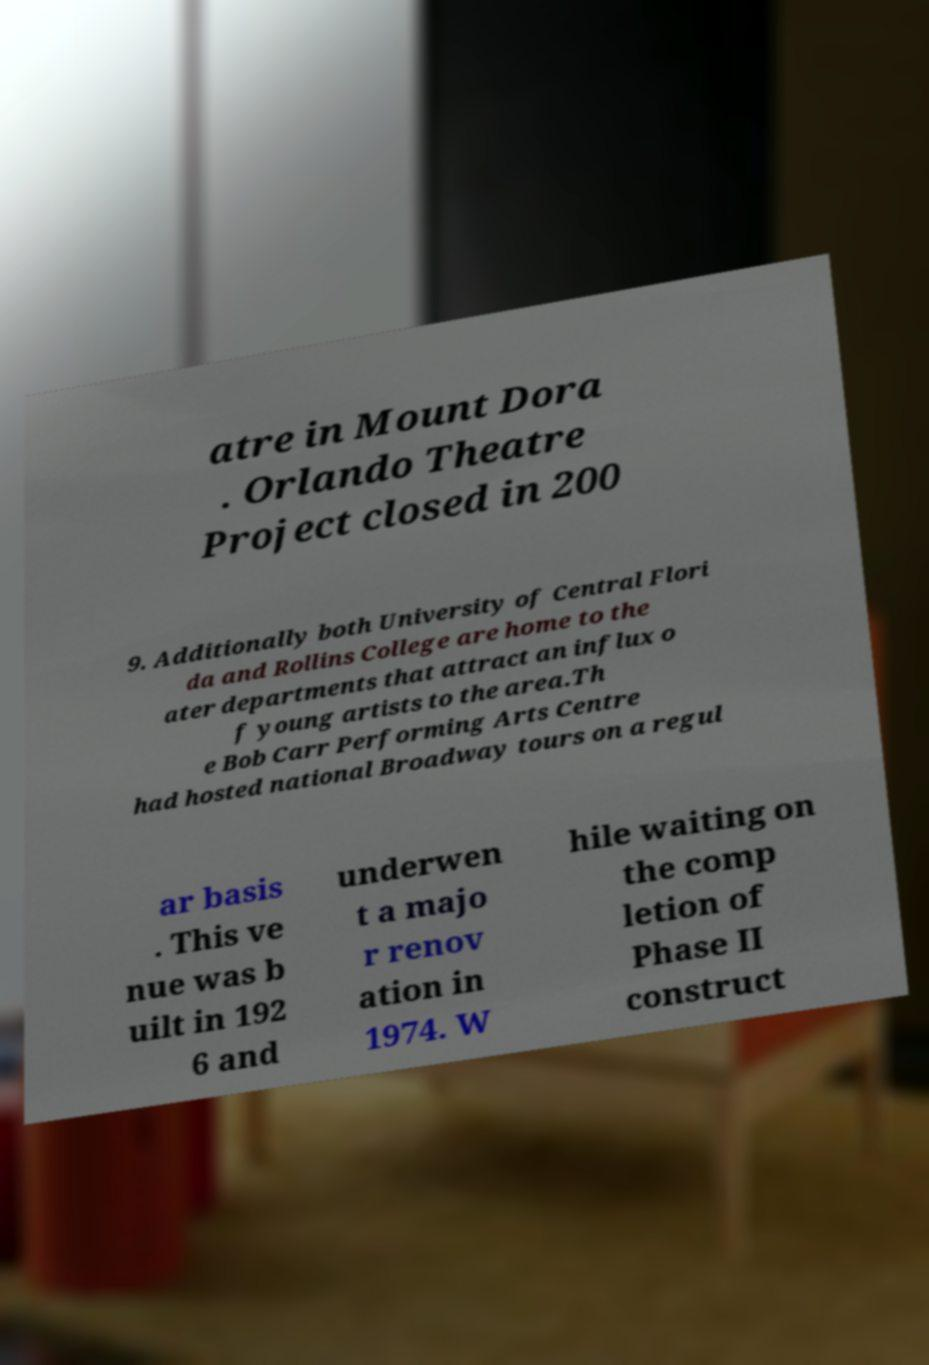Can you accurately transcribe the text from the provided image for me? atre in Mount Dora . Orlando Theatre Project closed in 200 9. Additionally both University of Central Flori da and Rollins College are home to the ater departments that attract an influx o f young artists to the area.Th e Bob Carr Performing Arts Centre had hosted national Broadway tours on a regul ar basis . This ve nue was b uilt in 192 6 and underwen t a majo r renov ation in 1974. W hile waiting on the comp letion of Phase II construct 